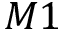Convert formula to latex. <formula><loc_0><loc_0><loc_500><loc_500>M 1</formula> 